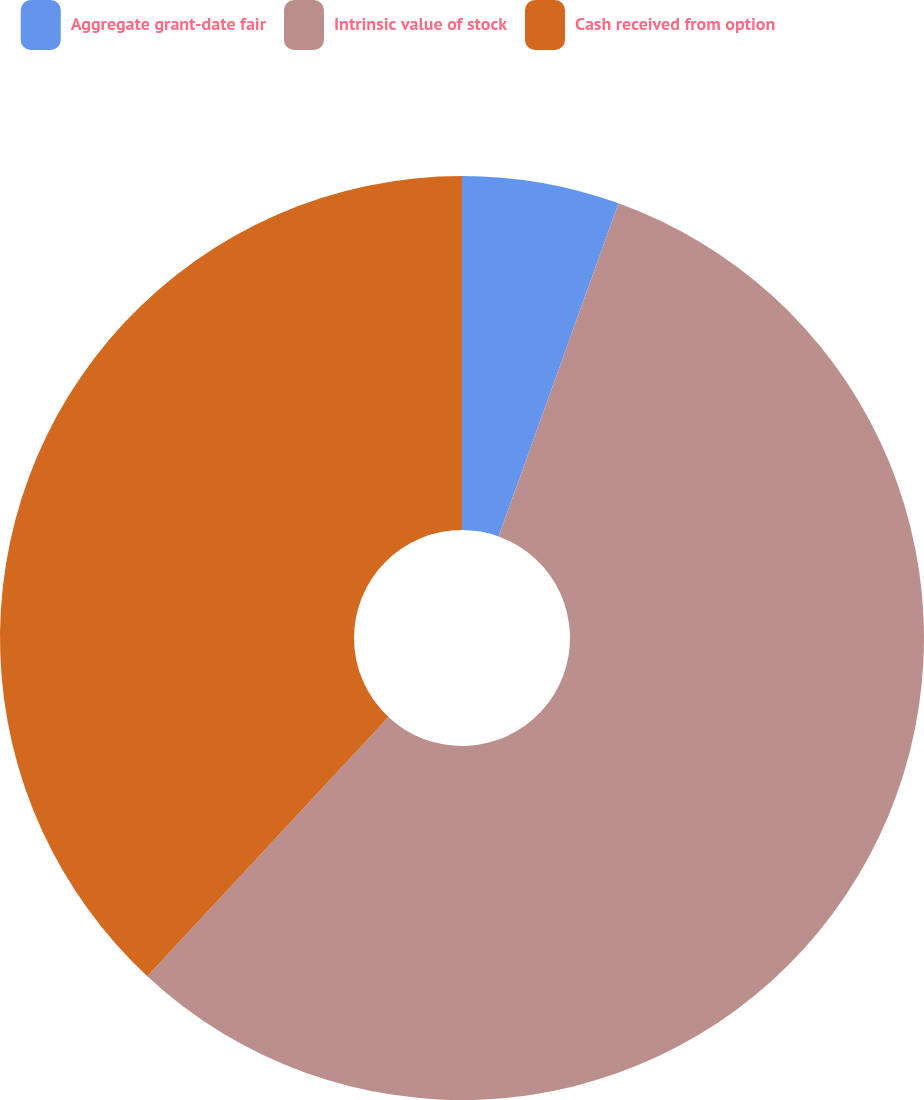Convert chart to OTSL. <chart><loc_0><loc_0><loc_500><loc_500><pie_chart><fcel>Aggregate grant-date fair<fcel>Intrinsic value of stock<fcel>Cash received from option<nl><fcel>5.5%<fcel>56.42%<fcel>38.07%<nl></chart> 